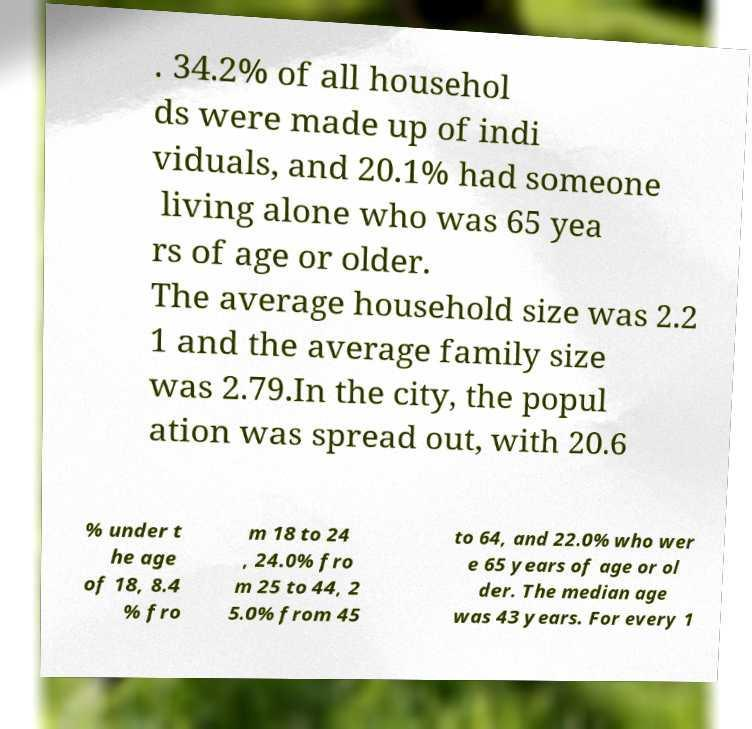Could you assist in decoding the text presented in this image and type it out clearly? . 34.2% of all househol ds were made up of indi viduals, and 20.1% had someone living alone who was 65 yea rs of age or older. The average household size was 2.2 1 and the average family size was 2.79.In the city, the popul ation was spread out, with 20.6 % under t he age of 18, 8.4 % fro m 18 to 24 , 24.0% fro m 25 to 44, 2 5.0% from 45 to 64, and 22.0% who wer e 65 years of age or ol der. The median age was 43 years. For every 1 